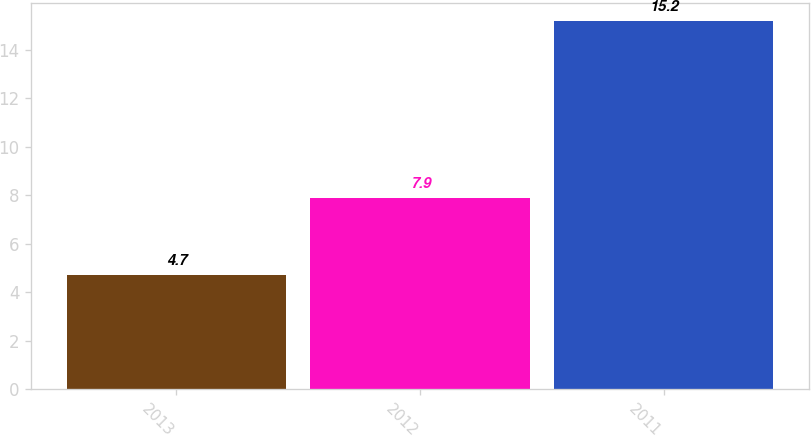<chart> <loc_0><loc_0><loc_500><loc_500><bar_chart><fcel>2013<fcel>2012<fcel>2011<nl><fcel>4.7<fcel>7.9<fcel>15.2<nl></chart> 